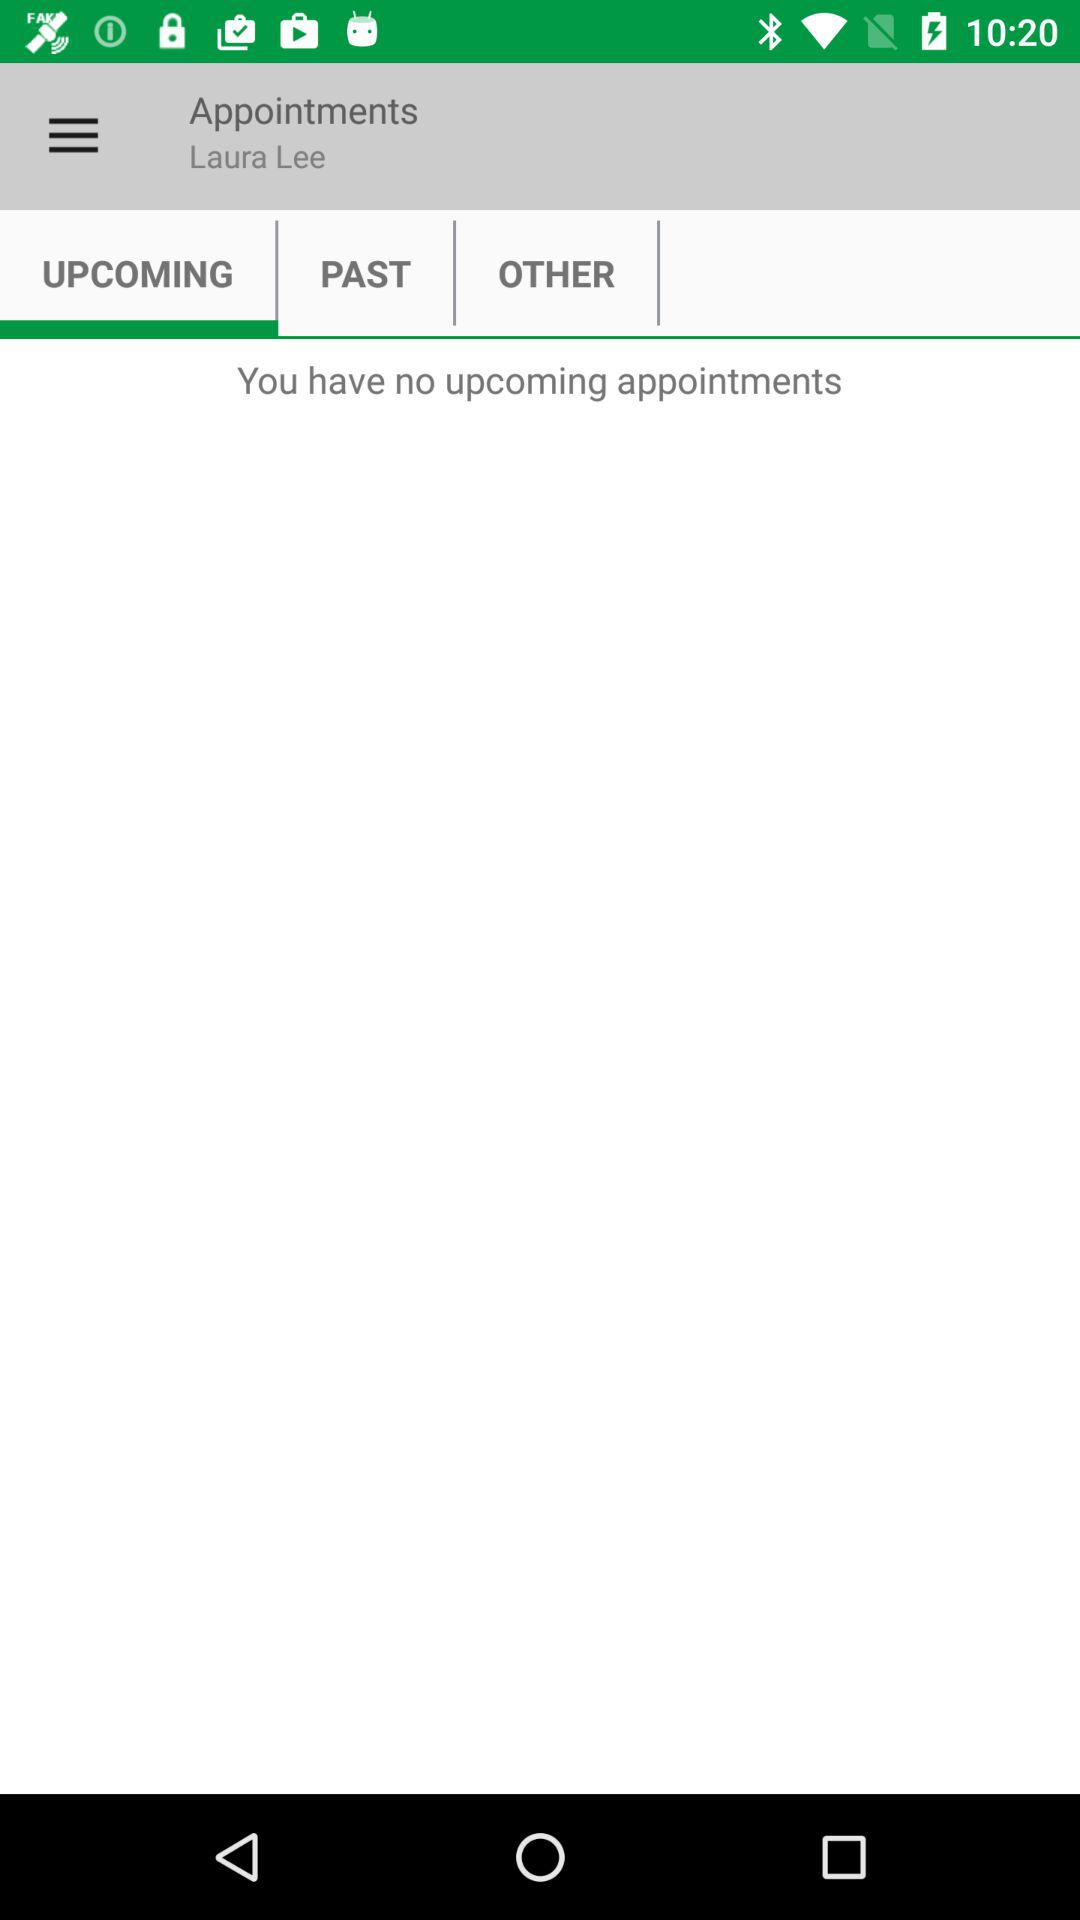Are there any upcoming appointments? There are no upcoming appointments. 